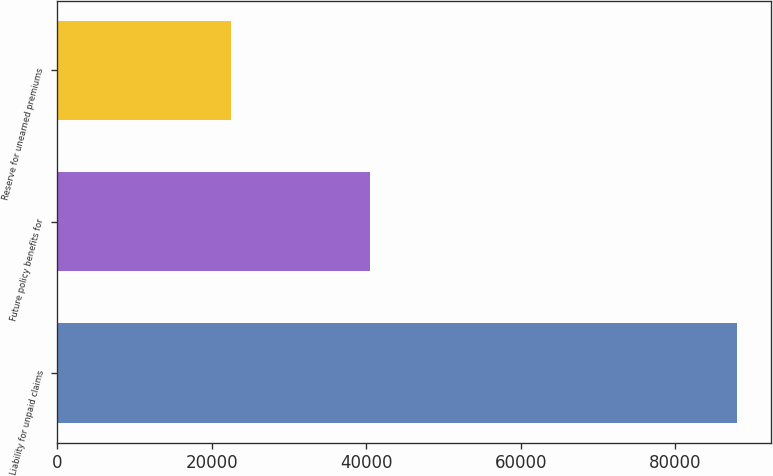Convert chart. <chart><loc_0><loc_0><loc_500><loc_500><bar_chart><fcel>Liability for unpaid claims<fcel>Future policy benefits for<fcel>Reserve for unearned premiums<nl><fcel>87991<fcel>40523<fcel>22537<nl></chart> 